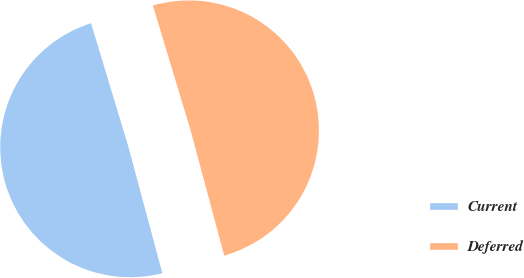Convert chart to OTSL. <chart><loc_0><loc_0><loc_500><loc_500><pie_chart><fcel>Current<fcel>Deferred<nl><fcel>49.5%<fcel>50.5%<nl></chart> 